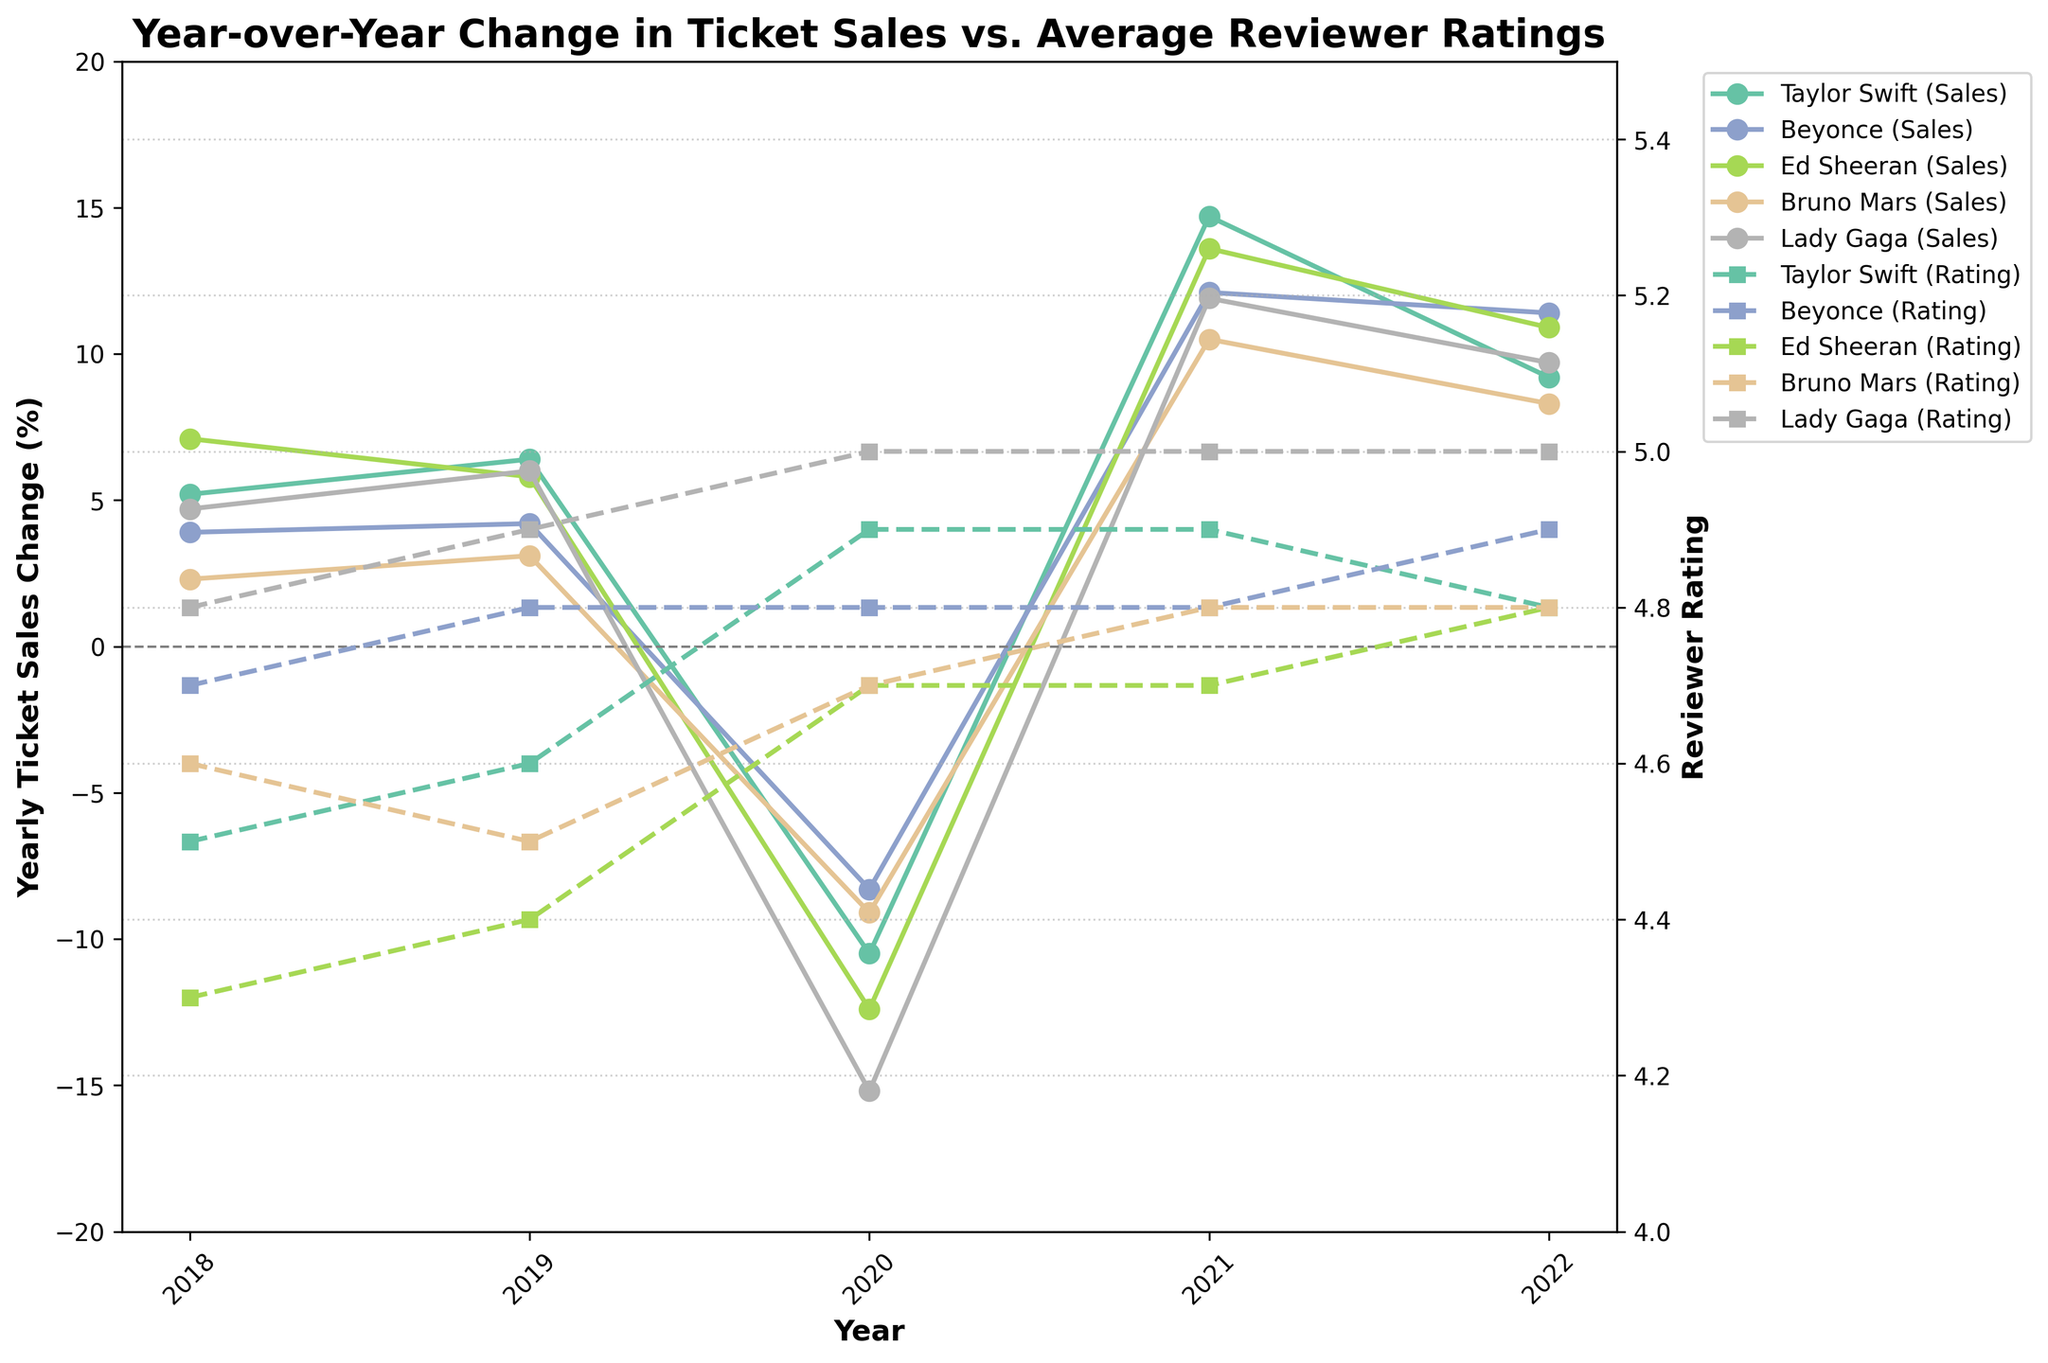What's the title of the plot? The title is located at the top of the plot and is often in a larger font size compared to the other text.
Answer: Year-over-Year Change in Ticket Sales vs. Average Reviewer Ratings What is the range of years represented on the x-axis? The x-axis displays the years each artist's data point is plotted against. By checking the first and last ticks on the x-axis, we can determine the range of years.
Answer: 2018 to 2022 Which artist had the highest Yearly Ticket Sales Change in 2021? We need to find the highest point on the Yearly Ticket Sales Change line for 2021 (check if Taylor Swift, Beyonce, Ed Sheeran, Bruno Mars, or Lady Gaga reaches the highest).
Answer: Taylor Swift How did Lady Gaga's yearly ticket sales change from 2020 to 2021? Find Lady Gaga's points for 2020 and 2021 on the Yearly Ticket Sales Change line. Compare these two values to determine the change.
Answer: Increased by 27.1% Between 2019 and 2020, which artist experienced the largest decrease in Yearly Ticket Sales Change? We need to examine the slope of each artist's line between 2019 and 2020 and identify the steepest negative slope.
Answer: Lady Gaga What is the average reviewer rating for Ed Sheeran from 2018 to 2022? Extract Ed Sheeran’s ratings for each year and calculate their average. This involves summing his ratings and dividing by the number of years.
Answer: 4.6 In which year did all artists experience a Yearly Ticket Sales Change in the negative range? Look for a year where the Yearly Ticket Sales Change lines for all artists are plotted below the horizontal axis set at 0%.
Answer: 2020 How do Taylor Swift's reviewer ratings compare to Beyonce's reviewer ratings from 2018 to 2022? Compare the points on the Reviewer Rating line for Taylor Swift and Beyonce for each year from 2018 to 2022. This involves directly comparing these parallel lines and noting which artist has higher values.
Answer: Taylor Swift generally has lower ratings than Beyonce What was the percentage change in ticket sales for Beyonce from 2019 to 2020 compared to 2020 to 2021? Calculate the difference in ticket sales from 2019 to 2020 and from 2020 to 2021 for Beyonce and compare these two changes.
Answer: -12.6% in 2019-2020, +20.4% in 2020-2021 Which year had the highest average reviewer rating across all artists? Extract the reviewer ratings for all artists for each year and calculate the average for each year. Identify which year has the highest average.
Answer: 2020 